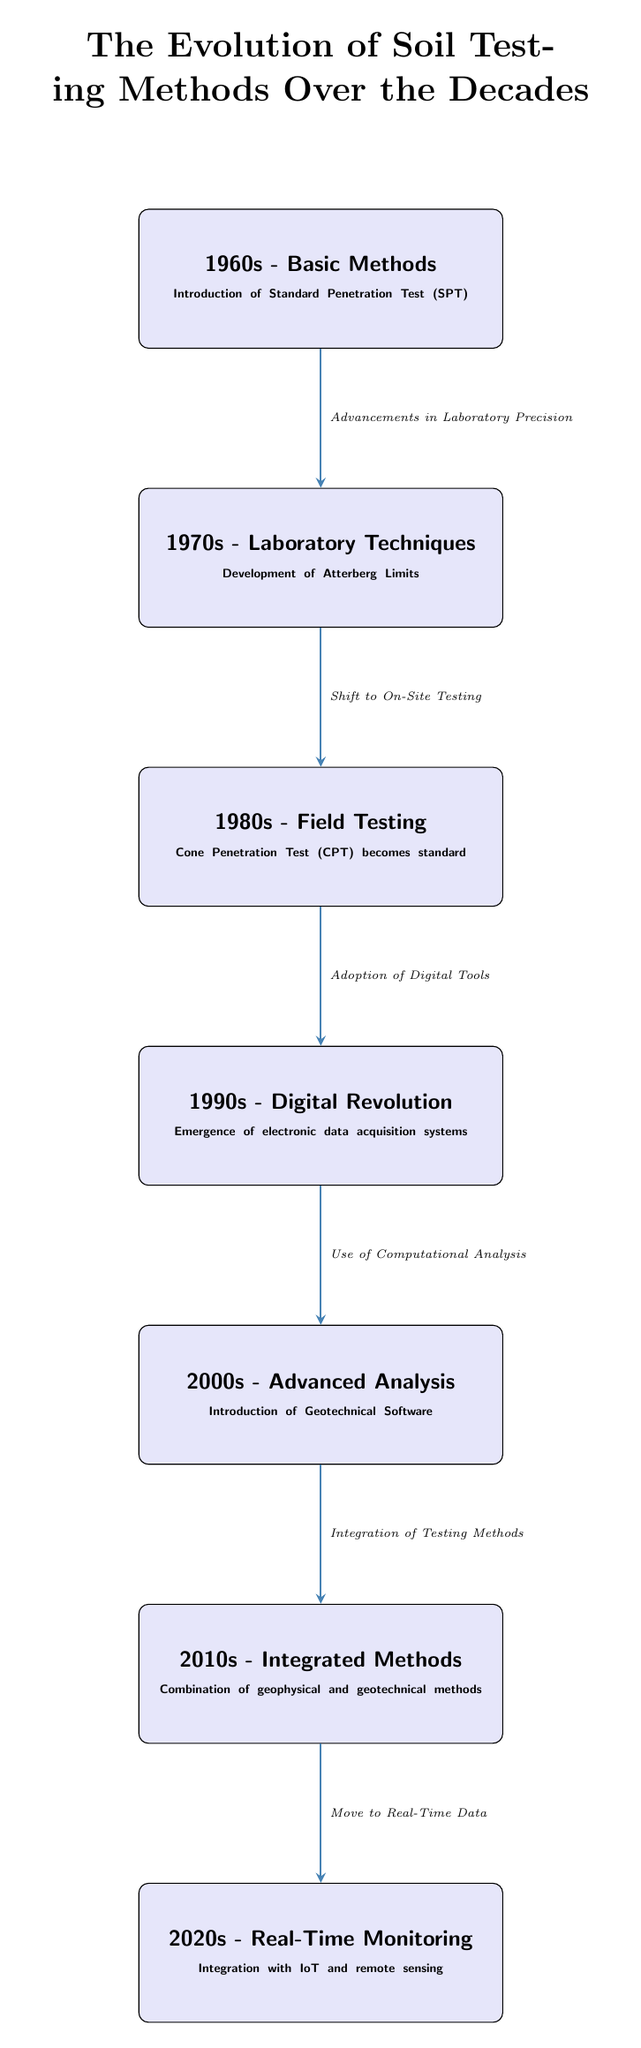What technique was first introduced in the 1960s? According to the diagram, the technique introduced in the 1960s is the Standard Penetration Test (SPT). This can be derived directly from the text within the box that corresponds to the 1960s.
Answer: Standard Penetration Test (SPT) How many years do each of the methodologies span? Each methodology represents a decade (10 years) as indicated by the decade labels on the nodes; therefore, the time span for each method is consistently 10 years.
Answer: 10 years What advancement facilitated the shift from the 1970s to the 1980s? The diagram indicates a shift from laboratory techniques to field testing as the primary focus of trench testing, specifically marked as "Shift to On-Site Testing" which explains this transition.
Answer: Shift to On-Site Testing What integration occurred in the 2010s? In the 2010s, the diagram highlights the integration of geophysical and geotechnical methods, which is a key focus in understanding how testing approaches evolved and became more holistic during that decade.
Answer: Combination of geophysical and geotechnical methods What was the main revolutionary change in the 1990s? The diagram describes the emergence of electronic data acquisition systems during the 1990s, which was a significant development that shifted how data was collected and processed in soil testing.
Answer: Emergence of electronic data acquisition systems How does the advancement in the 2000s relate to the previous decade? The diagram shows that the advancement in the 2000s, labeled as "Introduction of Geotechnical Software," is directly influenced by "Use of Computational Analysis" from the 1990s, highlighting a continuous integration of digital tools into soil testing methodologies.
Answer: Use of Computational Analysis What trend is reflected from the 2010s to the 2020s? The trend from the 2010s to the 2020s, according to the diagram, is the movement toward real-time data monitoring, emphasizing a greater reliance on technology to provide timely information for geotechnical investigations.
Answer: Move to Real-Time Data How many nodes are depicted in the diagram? The diagram features a total of seven nodes, representing each decade along with their respective advancements in soil testing methods. This number is determined by counting each labeled box.
Answer: Seven nodes What was the primary focus of soil testing in the 1980s? The primary focus of soil testing in the 1980s, as shown in the diagram, was the Cone Penetration Test (CPT), which became a standardized testing method during that period.
Answer: Cone Penetration Test (CPT) What does the arrow from the 2000s to the 2010s signify? The arrow connecting the 2000s and 2010s indicates the "Integration of Testing Methods," illustrating how advancements in geotechnical analysis led to combining various testing approaches effectively during that decade.
Answer: Integration of Testing Methods 